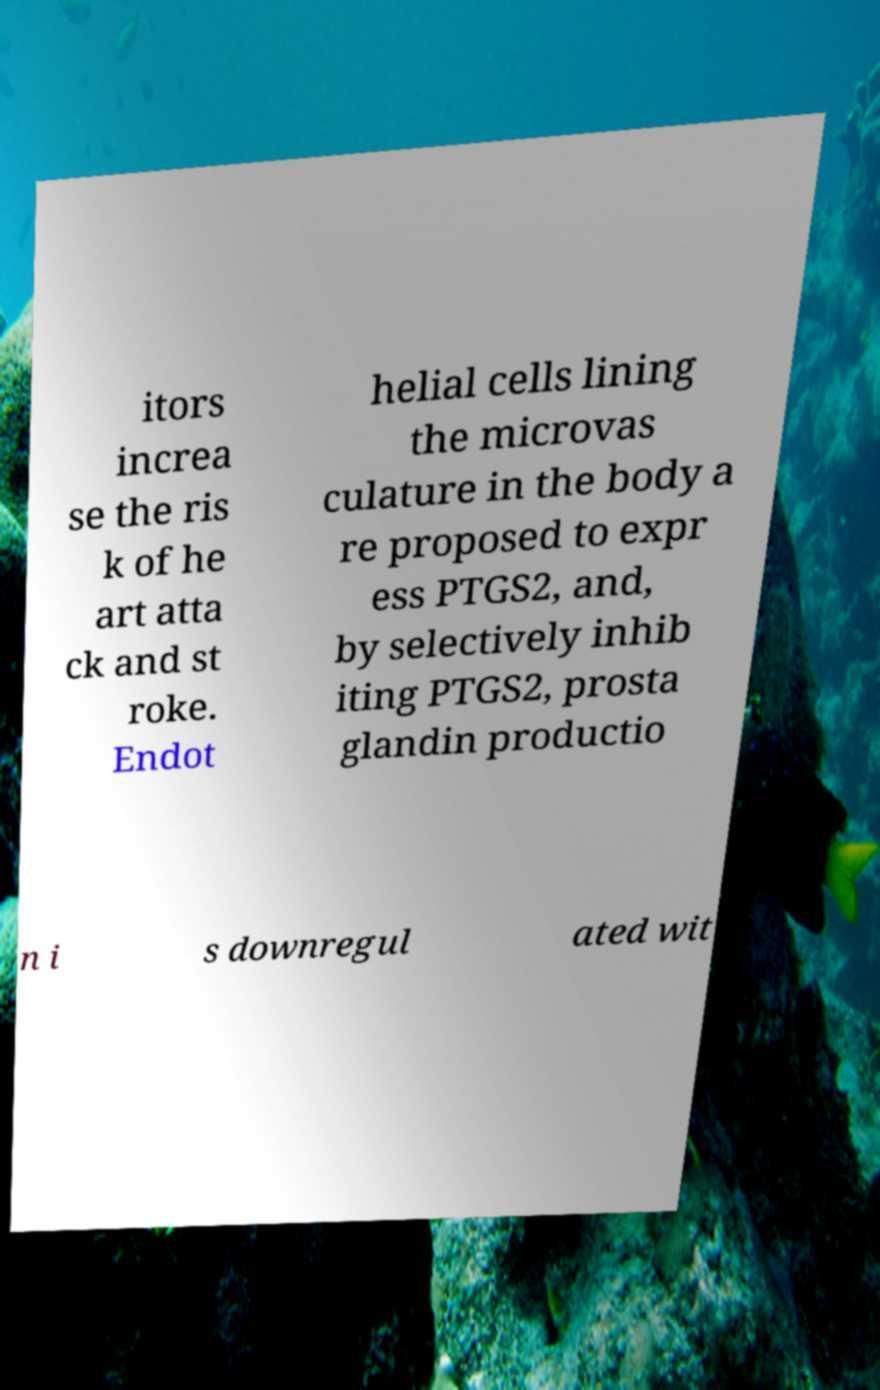Please read and relay the text visible in this image. What does it say? itors increa se the ris k of he art atta ck and st roke. Endot helial cells lining the microvas culature in the body a re proposed to expr ess PTGS2, and, by selectively inhib iting PTGS2, prosta glandin productio n i s downregul ated wit 